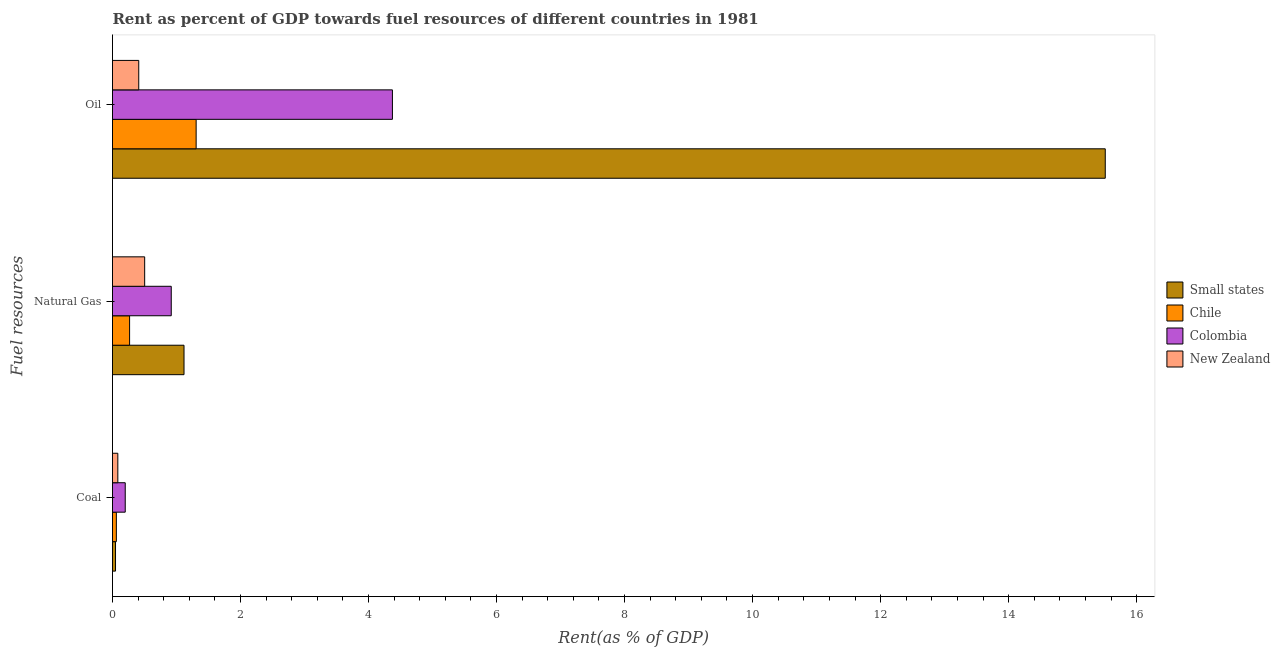How many bars are there on the 1st tick from the bottom?
Provide a succinct answer. 4. What is the label of the 3rd group of bars from the top?
Give a very brief answer. Coal. What is the rent towards natural gas in Colombia?
Offer a very short reply. 0.92. Across all countries, what is the maximum rent towards coal?
Offer a terse response. 0.2. Across all countries, what is the minimum rent towards coal?
Give a very brief answer. 0.05. In which country was the rent towards oil maximum?
Your response must be concise. Small states. In which country was the rent towards oil minimum?
Provide a succinct answer. New Zealand. What is the total rent towards natural gas in the graph?
Keep it short and to the point. 2.8. What is the difference between the rent towards coal in New Zealand and that in Colombia?
Provide a short and direct response. -0.12. What is the difference between the rent towards coal in New Zealand and the rent towards oil in Small states?
Your response must be concise. -15.43. What is the average rent towards natural gas per country?
Offer a terse response. 0.7. What is the difference between the rent towards oil and rent towards natural gas in New Zealand?
Your answer should be compact. -0.09. What is the ratio of the rent towards oil in Small states to that in New Zealand?
Your response must be concise. 37.81. What is the difference between the highest and the second highest rent towards natural gas?
Offer a very short reply. 0.2. What is the difference between the highest and the lowest rent towards natural gas?
Provide a short and direct response. 0.85. What does the 1st bar from the top in Natural Gas represents?
Offer a terse response. New Zealand. What does the 3rd bar from the bottom in Natural Gas represents?
Your response must be concise. Colombia. How many bars are there?
Make the answer very short. 12. How many countries are there in the graph?
Your response must be concise. 4. Does the graph contain any zero values?
Your answer should be very brief. No. How many legend labels are there?
Offer a very short reply. 4. How are the legend labels stacked?
Your answer should be compact. Vertical. What is the title of the graph?
Keep it short and to the point. Rent as percent of GDP towards fuel resources of different countries in 1981. Does "South Africa" appear as one of the legend labels in the graph?
Make the answer very short. No. What is the label or title of the X-axis?
Provide a succinct answer. Rent(as % of GDP). What is the label or title of the Y-axis?
Give a very brief answer. Fuel resources. What is the Rent(as % of GDP) in Small states in Coal?
Give a very brief answer. 0.05. What is the Rent(as % of GDP) in Chile in Coal?
Provide a succinct answer. 0.06. What is the Rent(as % of GDP) of Colombia in Coal?
Your answer should be very brief. 0.2. What is the Rent(as % of GDP) of New Zealand in Coal?
Your answer should be very brief. 0.08. What is the Rent(as % of GDP) in Small states in Natural Gas?
Ensure brevity in your answer.  1.12. What is the Rent(as % of GDP) of Chile in Natural Gas?
Your answer should be compact. 0.27. What is the Rent(as % of GDP) in Colombia in Natural Gas?
Provide a short and direct response. 0.92. What is the Rent(as % of GDP) in New Zealand in Natural Gas?
Provide a short and direct response. 0.5. What is the Rent(as % of GDP) of Small states in Oil?
Provide a short and direct response. 15.51. What is the Rent(as % of GDP) in Chile in Oil?
Keep it short and to the point. 1.31. What is the Rent(as % of GDP) of Colombia in Oil?
Offer a terse response. 4.37. What is the Rent(as % of GDP) in New Zealand in Oil?
Your answer should be compact. 0.41. Across all Fuel resources, what is the maximum Rent(as % of GDP) in Small states?
Make the answer very short. 15.51. Across all Fuel resources, what is the maximum Rent(as % of GDP) in Chile?
Provide a succinct answer. 1.31. Across all Fuel resources, what is the maximum Rent(as % of GDP) in Colombia?
Give a very brief answer. 4.37. Across all Fuel resources, what is the maximum Rent(as % of GDP) in New Zealand?
Your response must be concise. 0.5. Across all Fuel resources, what is the minimum Rent(as % of GDP) of Small states?
Provide a short and direct response. 0.05. Across all Fuel resources, what is the minimum Rent(as % of GDP) in Chile?
Give a very brief answer. 0.06. Across all Fuel resources, what is the minimum Rent(as % of GDP) in Colombia?
Provide a short and direct response. 0.2. Across all Fuel resources, what is the minimum Rent(as % of GDP) of New Zealand?
Keep it short and to the point. 0.08. What is the total Rent(as % of GDP) of Small states in the graph?
Your response must be concise. 16.67. What is the total Rent(as % of GDP) in Chile in the graph?
Provide a succinct answer. 1.63. What is the total Rent(as % of GDP) of Colombia in the graph?
Your answer should be very brief. 5.49. What is the difference between the Rent(as % of GDP) in Small states in Coal and that in Natural Gas?
Offer a very short reply. -1.07. What is the difference between the Rent(as % of GDP) of Chile in Coal and that in Natural Gas?
Your answer should be very brief. -0.21. What is the difference between the Rent(as % of GDP) in Colombia in Coal and that in Natural Gas?
Make the answer very short. -0.72. What is the difference between the Rent(as % of GDP) in New Zealand in Coal and that in Natural Gas?
Provide a succinct answer. -0.42. What is the difference between the Rent(as % of GDP) of Small states in Coal and that in Oil?
Give a very brief answer. -15.46. What is the difference between the Rent(as % of GDP) in Chile in Coal and that in Oil?
Offer a very short reply. -1.25. What is the difference between the Rent(as % of GDP) of Colombia in Coal and that in Oil?
Offer a terse response. -4.17. What is the difference between the Rent(as % of GDP) of New Zealand in Coal and that in Oil?
Keep it short and to the point. -0.33. What is the difference between the Rent(as % of GDP) in Small states in Natural Gas and that in Oil?
Keep it short and to the point. -14.39. What is the difference between the Rent(as % of GDP) of Chile in Natural Gas and that in Oil?
Make the answer very short. -1.04. What is the difference between the Rent(as % of GDP) of Colombia in Natural Gas and that in Oil?
Your response must be concise. -3.46. What is the difference between the Rent(as % of GDP) in New Zealand in Natural Gas and that in Oil?
Make the answer very short. 0.09. What is the difference between the Rent(as % of GDP) in Small states in Coal and the Rent(as % of GDP) in Chile in Natural Gas?
Provide a succinct answer. -0.22. What is the difference between the Rent(as % of GDP) in Small states in Coal and the Rent(as % of GDP) in Colombia in Natural Gas?
Offer a terse response. -0.87. What is the difference between the Rent(as % of GDP) of Small states in Coal and the Rent(as % of GDP) of New Zealand in Natural Gas?
Provide a succinct answer. -0.46. What is the difference between the Rent(as % of GDP) in Chile in Coal and the Rent(as % of GDP) in Colombia in Natural Gas?
Your answer should be compact. -0.86. What is the difference between the Rent(as % of GDP) of Chile in Coal and the Rent(as % of GDP) of New Zealand in Natural Gas?
Make the answer very short. -0.44. What is the difference between the Rent(as % of GDP) in Colombia in Coal and the Rent(as % of GDP) in New Zealand in Natural Gas?
Your answer should be very brief. -0.3. What is the difference between the Rent(as % of GDP) of Small states in Coal and the Rent(as % of GDP) of Chile in Oil?
Your answer should be very brief. -1.26. What is the difference between the Rent(as % of GDP) of Small states in Coal and the Rent(as % of GDP) of Colombia in Oil?
Provide a succinct answer. -4.33. What is the difference between the Rent(as % of GDP) in Small states in Coal and the Rent(as % of GDP) in New Zealand in Oil?
Ensure brevity in your answer.  -0.36. What is the difference between the Rent(as % of GDP) of Chile in Coal and the Rent(as % of GDP) of Colombia in Oil?
Offer a terse response. -4.31. What is the difference between the Rent(as % of GDP) in Chile in Coal and the Rent(as % of GDP) in New Zealand in Oil?
Offer a terse response. -0.35. What is the difference between the Rent(as % of GDP) in Colombia in Coal and the Rent(as % of GDP) in New Zealand in Oil?
Offer a terse response. -0.21. What is the difference between the Rent(as % of GDP) in Small states in Natural Gas and the Rent(as % of GDP) in Chile in Oil?
Your answer should be very brief. -0.19. What is the difference between the Rent(as % of GDP) of Small states in Natural Gas and the Rent(as % of GDP) of Colombia in Oil?
Your answer should be compact. -3.26. What is the difference between the Rent(as % of GDP) of Small states in Natural Gas and the Rent(as % of GDP) of New Zealand in Oil?
Keep it short and to the point. 0.71. What is the difference between the Rent(as % of GDP) in Chile in Natural Gas and the Rent(as % of GDP) in Colombia in Oil?
Your answer should be compact. -4.11. What is the difference between the Rent(as % of GDP) in Chile in Natural Gas and the Rent(as % of GDP) in New Zealand in Oil?
Offer a terse response. -0.14. What is the difference between the Rent(as % of GDP) of Colombia in Natural Gas and the Rent(as % of GDP) of New Zealand in Oil?
Keep it short and to the point. 0.51. What is the average Rent(as % of GDP) of Small states per Fuel resources?
Offer a very short reply. 5.56. What is the average Rent(as % of GDP) of Chile per Fuel resources?
Give a very brief answer. 0.54. What is the average Rent(as % of GDP) in Colombia per Fuel resources?
Offer a very short reply. 1.83. What is the average Rent(as % of GDP) in New Zealand per Fuel resources?
Ensure brevity in your answer.  0.33. What is the difference between the Rent(as % of GDP) of Small states and Rent(as % of GDP) of Chile in Coal?
Ensure brevity in your answer.  -0.01. What is the difference between the Rent(as % of GDP) of Small states and Rent(as % of GDP) of Colombia in Coal?
Provide a short and direct response. -0.15. What is the difference between the Rent(as % of GDP) of Small states and Rent(as % of GDP) of New Zealand in Coal?
Your answer should be very brief. -0.04. What is the difference between the Rent(as % of GDP) of Chile and Rent(as % of GDP) of Colombia in Coal?
Give a very brief answer. -0.14. What is the difference between the Rent(as % of GDP) in Chile and Rent(as % of GDP) in New Zealand in Coal?
Make the answer very short. -0.02. What is the difference between the Rent(as % of GDP) in Colombia and Rent(as % of GDP) in New Zealand in Coal?
Provide a short and direct response. 0.12. What is the difference between the Rent(as % of GDP) in Small states and Rent(as % of GDP) in Chile in Natural Gas?
Ensure brevity in your answer.  0.85. What is the difference between the Rent(as % of GDP) of Small states and Rent(as % of GDP) of Colombia in Natural Gas?
Give a very brief answer. 0.2. What is the difference between the Rent(as % of GDP) in Small states and Rent(as % of GDP) in New Zealand in Natural Gas?
Offer a very short reply. 0.61. What is the difference between the Rent(as % of GDP) in Chile and Rent(as % of GDP) in Colombia in Natural Gas?
Ensure brevity in your answer.  -0.65. What is the difference between the Rent(as % of GDP) in Chile and Rent(as % of GDP) in New Zealand in Natural Gas?
Your answer should be very brief. -0.24. What is the difference between the Rent(as % of GDP) in Colombia and Rent(as % of GDP) in New Zealand in Natural Gas?
Your answer should be very brief. 0.42. What is the difference between the Rent(as % of GDP) in Small states and Rent(as % of GDP) in Chile in Oil?
Keep it short and to the point. 14.2. What is the difference between the Rent(as % of GDP) of Small states and Rent(as % of GDP) of Colombia in Oil?
Provide a short and direct response. 11.14. What is the difference between the Rent(as % of GDP) of Small states and Rent(as % of GDP) of New Zealand in Oil?
Provide a short and direct response. 15.1. What is the difference between the Rent(as % of GDP) of Chile and Rent(as % of GDP) of Colombia in Oil?
Offer a terse response. -3.07. What is the difference between the Rent(as % of GDP) of Chile and Rent(as % of GDP) of New Zealand in Oil?
Provide a succinct answer. 0.9. What is the difference between the Rent(as % of GDP) in Colombia and Rent(as % of GDP) in New Zealand in Oil?
Your answer should be compact. 3.96. What is the ratio of the Rent(as % of GDP) in Small states in Coal to that in Natural Gas?
Provide a succinct answer. 0.04. What is the ratio of the Rent(as % of GDP) in Chile in Coal to that in Natural Gas?
Make the answer very short. 0.23. What is the ratio of the Rent(as % of GDP) of Colombia in Coal to that in Natural Gas?
Provide a short and direct response. 0.22. What is the ratio of the Rent(as % of GDP) in New Zealand in Coal to that in Natural Gas?
Your answer should be very brief. 0.17. What is the ratio of the Rent(as % of GDP) in Small states in Coal to that in Oil?
Make the answer very short. 0. What is the ratio of the Rent(as % of GDP) in Chile in Coal to that in Oil?
Offer a very short reply. 0.05. What is the ratio of the Rent(as % of GDP) in Colombia in Coal to that in Oil?
Provide a succinct answer. 0.05. What is the ratio of the Rent(as % of GDP) of New Zealand in Coal to that in Oil?
Your answer should be compact. 0.2. What is the ratio of the Rent(as % of GDP) of Small states in Natural Gas to that in Oil?
Offer a terse response. 0.07. What is the ratio of the Rent(as % of GDP) of Chile in Natural Gas to that in Oil?
Your answer should be compact. 0.2. What is the ratio of the Rent(as % of GDP) of Colombia in Natural Gas to that in Oil?
Offer a terse response. 0.21. What is the ratio of the Rent(as % of GDP) in New Zealand in Natural Gas to that in Oil?
Offer a very short reply. 1.23. What is the difference between the highest and the second highest Rent(as % of GDP) of Small states?
Offer a very short reply. 14.39. What is the difference between the highest and the second highest Rent(as % of GDP) of Chile?
Your answer should be compact. 1.04. What is the difference between the highest and the second highest Rent(as % of GDP) in Colombia?
Offer a very short reply. 3.46. What is the difference between the highest and the second highest Rent(as % of GDP) of New Zealand?
Ensure brevity in your answer.  0.09. What is the difference between the highest and the lowest Rent(as % of GDP) in Small states?
Your response must be concise. 15.46. What is the difference between the highest and the lowest Rent(as % of GDP) of Chile?
Your answer should be very brief. 1.25. What is the difference between the highest and the lowest Rent(as % of GDP) of Colombia?
Give a very brief answer. 4.17. What is the difference between the highest and the lowest Rent(as % of GDP) in New Zealand?
Offer a terse response. 0.42. 